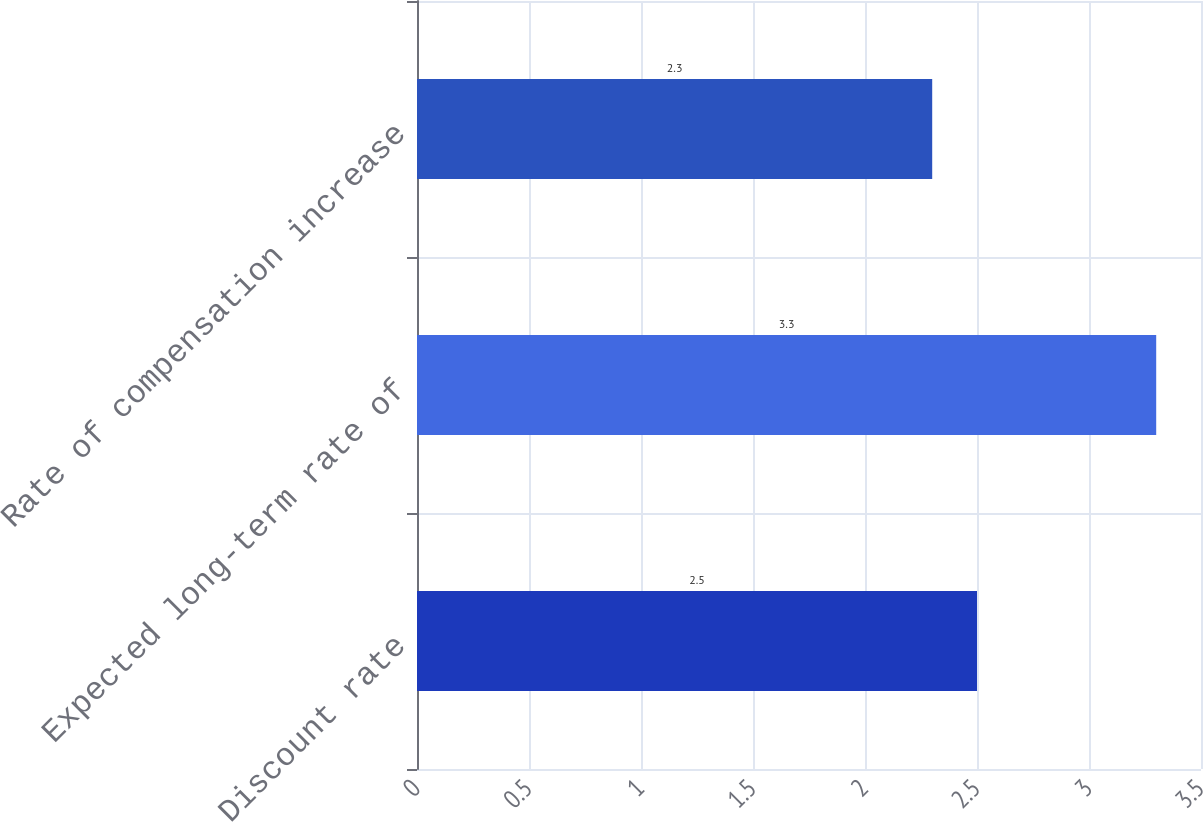Convert chart to OTSL. <chart><loc_0><loc_0><loc_500><loc_500><bar_chart><fcel>Discount rate<fcel>Expected long-term rate of<fcel>Rate of compensation increase<nl><fcel>2.5<fcel>3.3<fcel>2.3<nl></chart> 